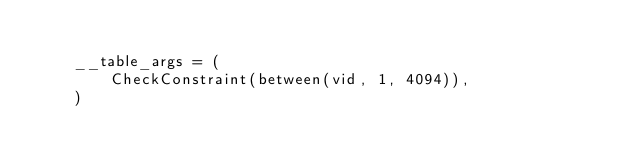Convert code to text. <code><loc_0><loc_0><loc_500><loc_500><_Python_>
    __table_args = (
        CheckConstraint(between(vid, 1, 4094)),
    )</code> 